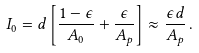Convert formula to latex. <formula><loc_0><loc_0><loc_500><loc_500>I _ { 0 } = d \left [ \frac { 1 - \epsilon } { A _ { 0 } } + \frac { \epsilon } { A _ { p } } \right ] \approx \frac { \epsilon d } { A _ { p } } \, .</formula> 